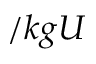<formula> <loc_0><loc_0><loc_500><loc_500>\ / k g U</formula> 